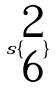<formula> <loc_0><loc_0><loc_500><loc_500>s \{ \begin{matrix} 2 \\ 6 \end{matrix} \}</formula> 